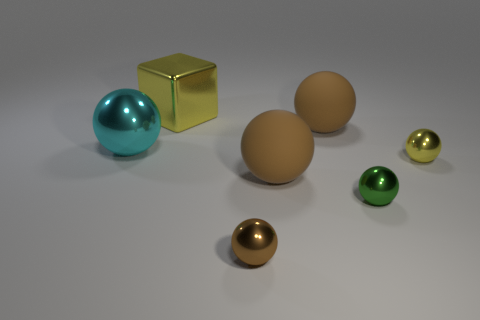Subtract all cyan cylinders. How many brown balls are left? 3 Subtract all green balls. How many balls are left? 5 Subtract all rubber spheres. How many spheres are left? 4 Subtract all yellow spheres. Subtract all purple cubes. How many spheres are left? 5 Add 1 small brown metallic objects. How many objects exist? 8 Subtract all spheres. How many objects are left? 1 Subtract 0 blue blocks. How many objects are left? 7 Subtract all brown balls. Subtract all big metal objects. How many objects are left? 2 Add 4 metal objects. How many metal objects are left? 9 Add 1 large cyan shiny objects. How many large cyan shiny objects exist? 2 